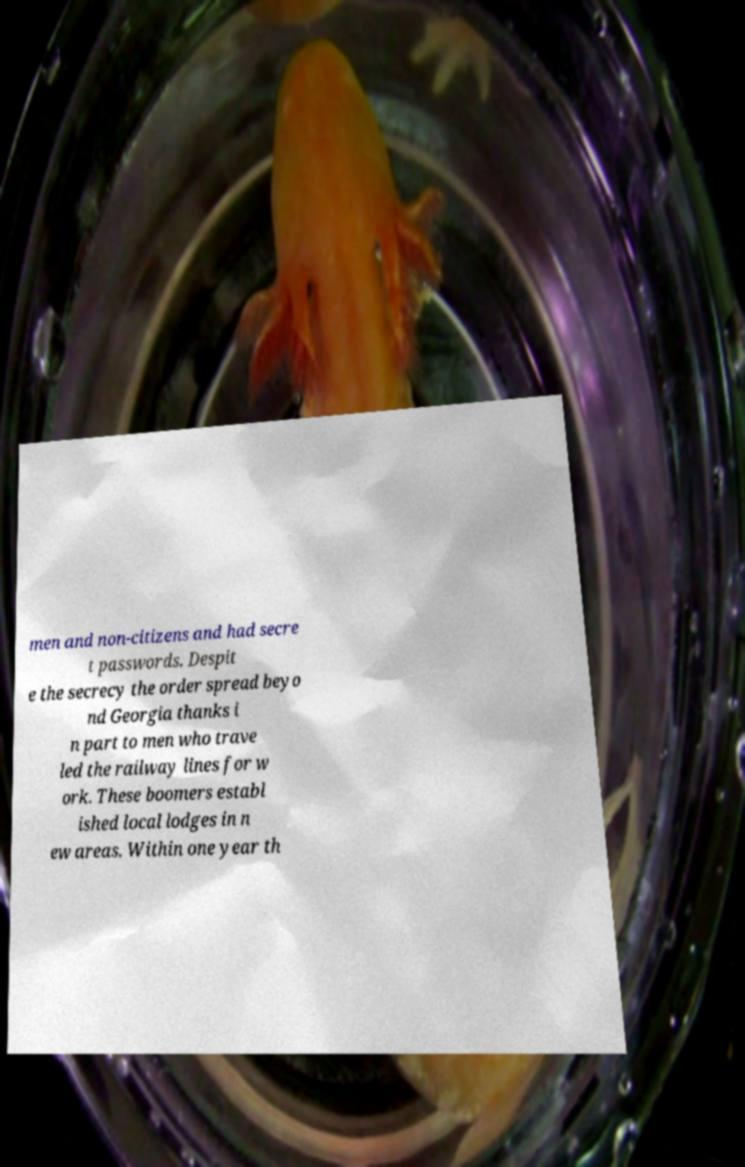Can you read and provide the text displayed in the image?This photo seems to have some interesting text. Can you extract and type it out for me? men and non-citizens and had secre t passwords. Despit e the secrecy the order spread beyo nd Georgia thanks i n part to men who trave led the railway lines for w ork. These boomers establ ished local lodges in n ew areas. Within one year th 